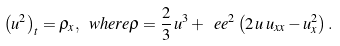Convert formula to latex. <formula><loc_0><loc_0><loc_500><loc_500>\left ( u ^ { 2 } \right ) _ { t } = \rho _ { x } , \ w h e r e \rho = \frac { 2 } { 3 } \, u ^ { 3 } + \ e e ^ { 2 } \left ( 2 \, u \, u _ { x x } - u _ { x } ^ { 2 } \right ) .</formula> 